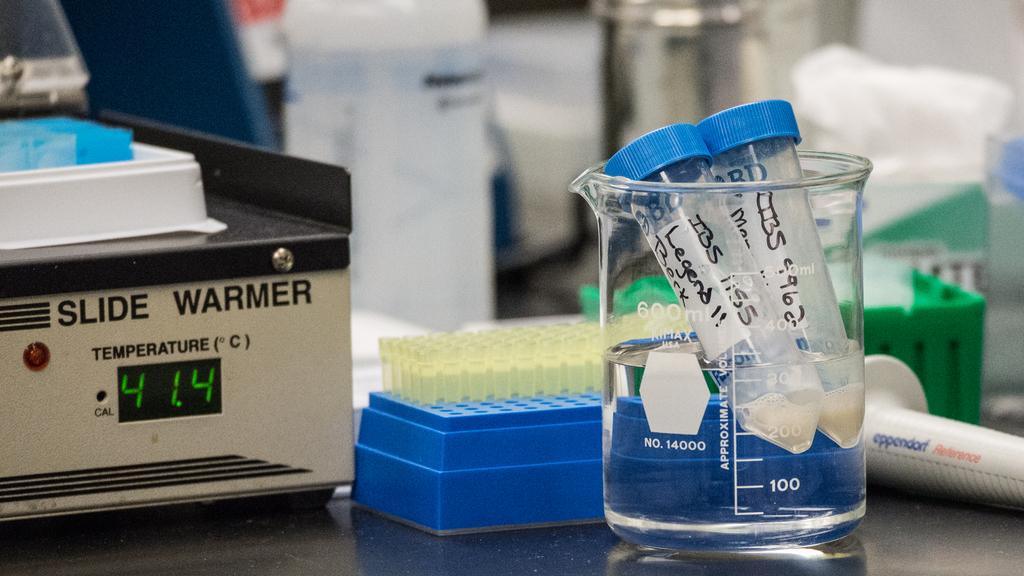What temperature is the slide warmer set to?
Offer a terse response. 41.4. 